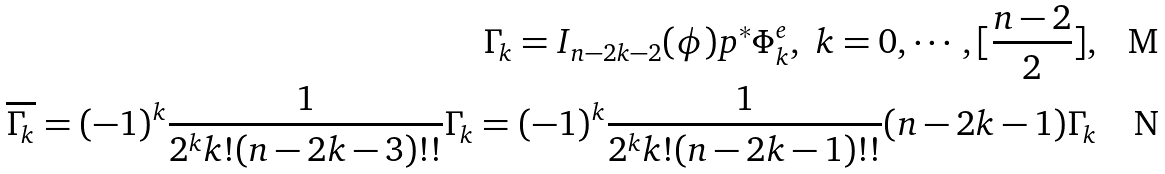Convert formula to latex. <formula><loc_0><loc_0><loc_500><loc_500>\Gamma _ { k } = I _ { n - 2 k - 2 } ( \phi ) p ^ { * } \Phi ^ { e } _ { k } , \ k = 0 , \cdots , [ \frac { n - 2 } 2 ] , \\ \overline { \Gamma _ { k } } = ( - 1 ) ^ { k } \frac { 1 } { 2 ^ { k } k ! ( n - 2 k - 3 ) ! ! } \Gamma _ { k } = ( - 1 ) ^ { k } \frac { 1 } { 2 ^ { k } k ! ( n - 2 k - 1 ) ! ! } ( n - 2 k - 1 ) \Gamma _ { k }</formula> 